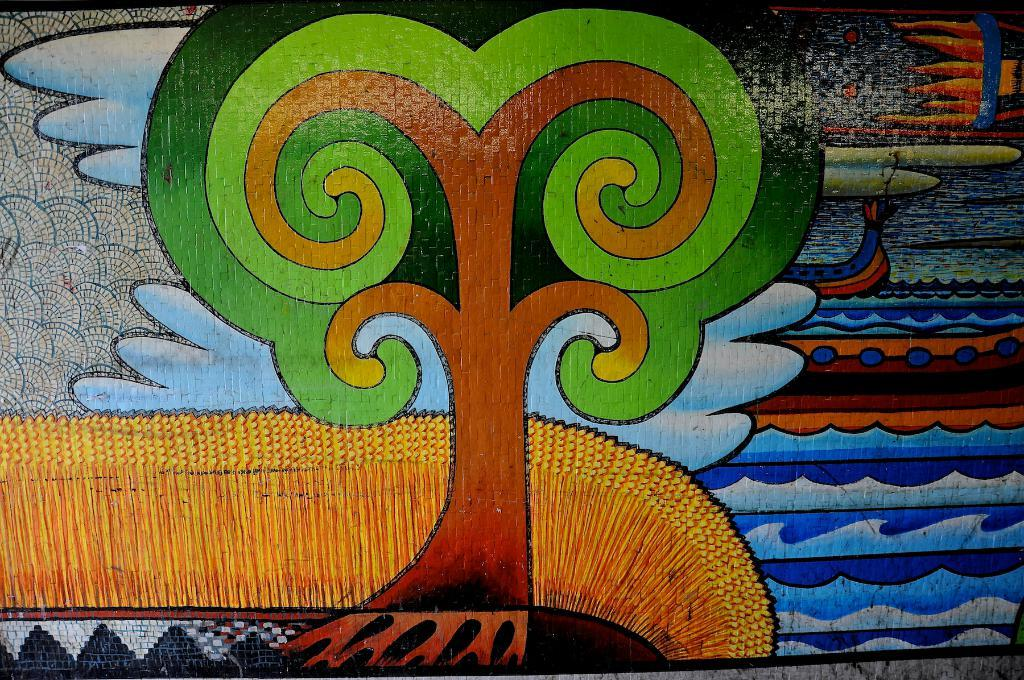What is hanging on the wall in the image? There is a painting on the wall in the image. What type of rhythm can be heard coming from the painting in the image? There is no rhythm present in the painting, as it is a static visual art piece. 